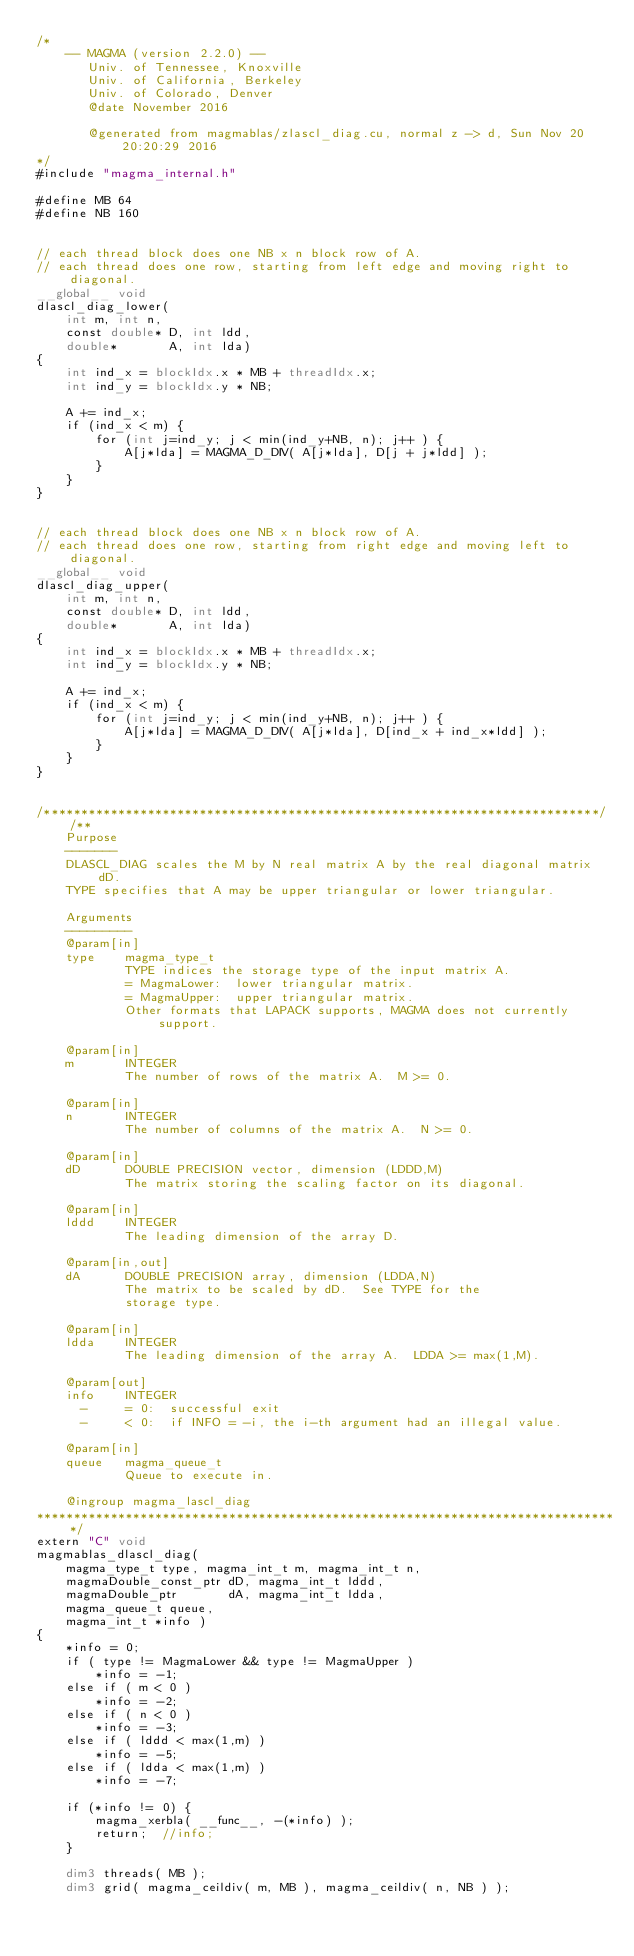Convert code to text. <code><loc_0><loc_0><loc_500><loc_500><_Cuda_>/*
    -- MAGMA (version 2.2.0) --
       Univ. of Tennessee, Knoxville
       Univ. of California, Berkeley
       Univ. of Colorado, Denver
       @date November 2016

       @generated from magmablas/zlascl_diag.cu, normal z -> d, Sun Nov 20 20:20:29 2016
*/
#include "magma_internal.h"

#define MB 64
#define NB 160


// each thread block does one NB x n block row of A.
// each thread does one row, starting from left edge and moving right to diagonal.
__global__ void
dlascl_diag_lower(
    int m, int n,
    const double* D, int ldd,
    double*       A, int lda)
{
    int ind_x = blockIdx.x * MB + threadIdx.x;
    int ind_y = blockIdx.y * NB;

    A += ind_x;
    if (ind_x < m) {
        for (int j=ind_y; j < min(ind_y+NB, n); j++ ) {
            A[j*lda] = MAGMA_D_DIV( A[j*lda], D[j + j*ldd] );
        }
    }
}


// each thread block does one NB x n block row of A.
// each thread does one row, starting from right edge and moving left to diagonal.
__global__ void
dlascl_diag_upper(
    int m, int n,
    const double* D, int ldd,
    double*       A, int lda)
{
    int ind_x = blockIdx.x * MB + threadIdx.x;
    int ind_y = blockIdx.y * NB;

    A += ind_x;
    if (ind_x < m) {
        for (int j=ind_y; j < min(ind_y+NB, n); j++ ) {
            A[j*lda] = MAGMA_D_DIV( A[j*lda], D[ind_x + ind_x*ldd] );
        }
    }
}


/***************************************************************************//**
    Purpose
    -------
    DLASCL_DIAG scales the M by N real matrix A by the real diagonal matrix dD.
    TYPE specifies that A may be upper triangular or lower triangular.

    Arguments
    ---------
    @param[in]
    type    magma_type_t
            TYPE indices the storage type of the input matrix A.
            = MagmaLower:  lower triangular matrix.
            = MagmaUpper:  upper triangular matrix.
            Other formats that LAPACK supports, MAGMA does not currently support.

    @param[in]
    m       INTEGER
            The number of rows of the matrix A.  M >= 0.

    @param[in]
    n       INTEGER
            The number of columns of the matrix A.  N >= 0.

    @param[in]
    dD      DOUBLE PRECISION vector, dimension (LDDD,M)
            The matrix storing the scaling factor on its diagonal.

    @param[in]
    lddd    INTEGER
            The leading dimension of the array D.

    @param[in,out]
    dA      DOUBLE PRECISION array, dimension (LDDA,N)
            The matrix to be scaled by dD.  See TYPE for the
            storage type.

    @param[in]
    ldda    INTEGER
            The leading dimension of the array A.  LDDA >= max(1,M).

    @param[out]
    info    INTEGER
      -     = 0:  successful exit
      -     < 0:  if INFO = -i, the i-th argument had an illegal value.

    @param[in]
    queue   magma_queue_t
            Queue to execute in.

    @ingroup magma_lascl_diag
*******************************************************************************/
extern "C" void
magmablas_dlascl_diag(
    magma_type_t type, magma_int_t m, magma_int_t n,
    magmaDouble_const_ptr dD, magma_int_t lddd,
    magmaDouble_ptr       dA, magma_int_t ldda,
    magma_queue_t queue,
    magma_int_t *info )
{
    *info = 0;
    if ( type != MagmaLower && type != MagmaUpper )
        *info = -1;
    else if ( m < 0 )
        *info = -2;
    else if ( n < 0 )
        *info = -3;
    else if ( lddd < max(1,m) )
        *info = -5;
    else if ( ldda < max(1,m) )
        *info = -7;
    
    if (*info != 0) {
        magma_xerbla( __func__, -(*info) );
        return;  //info;
    }
    
    dim3 threads( MB );
    dim3 grid( magma_ceildiv( m, MB ), magma_ceildiv( n, NB ) );
    </code> 